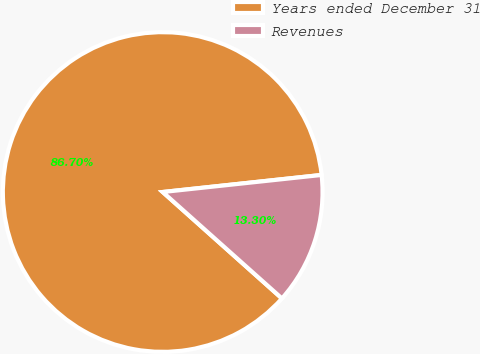Convert chart to OTSL. <chart><loc_0><loc_0><loc_500><loc_500><pie_chart><fcel>Years ended December 31<fcel>Revenues<nl><fcel>86.7%<fcel>13.3%<nl></chart> 